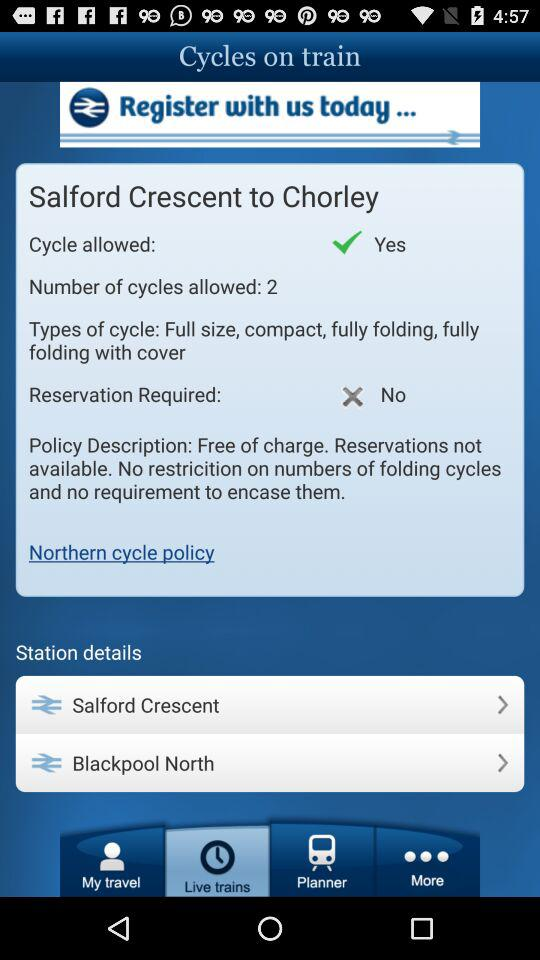How many types of cycles are allowed on the train?
Answer the question using a single word or phrase. 4 